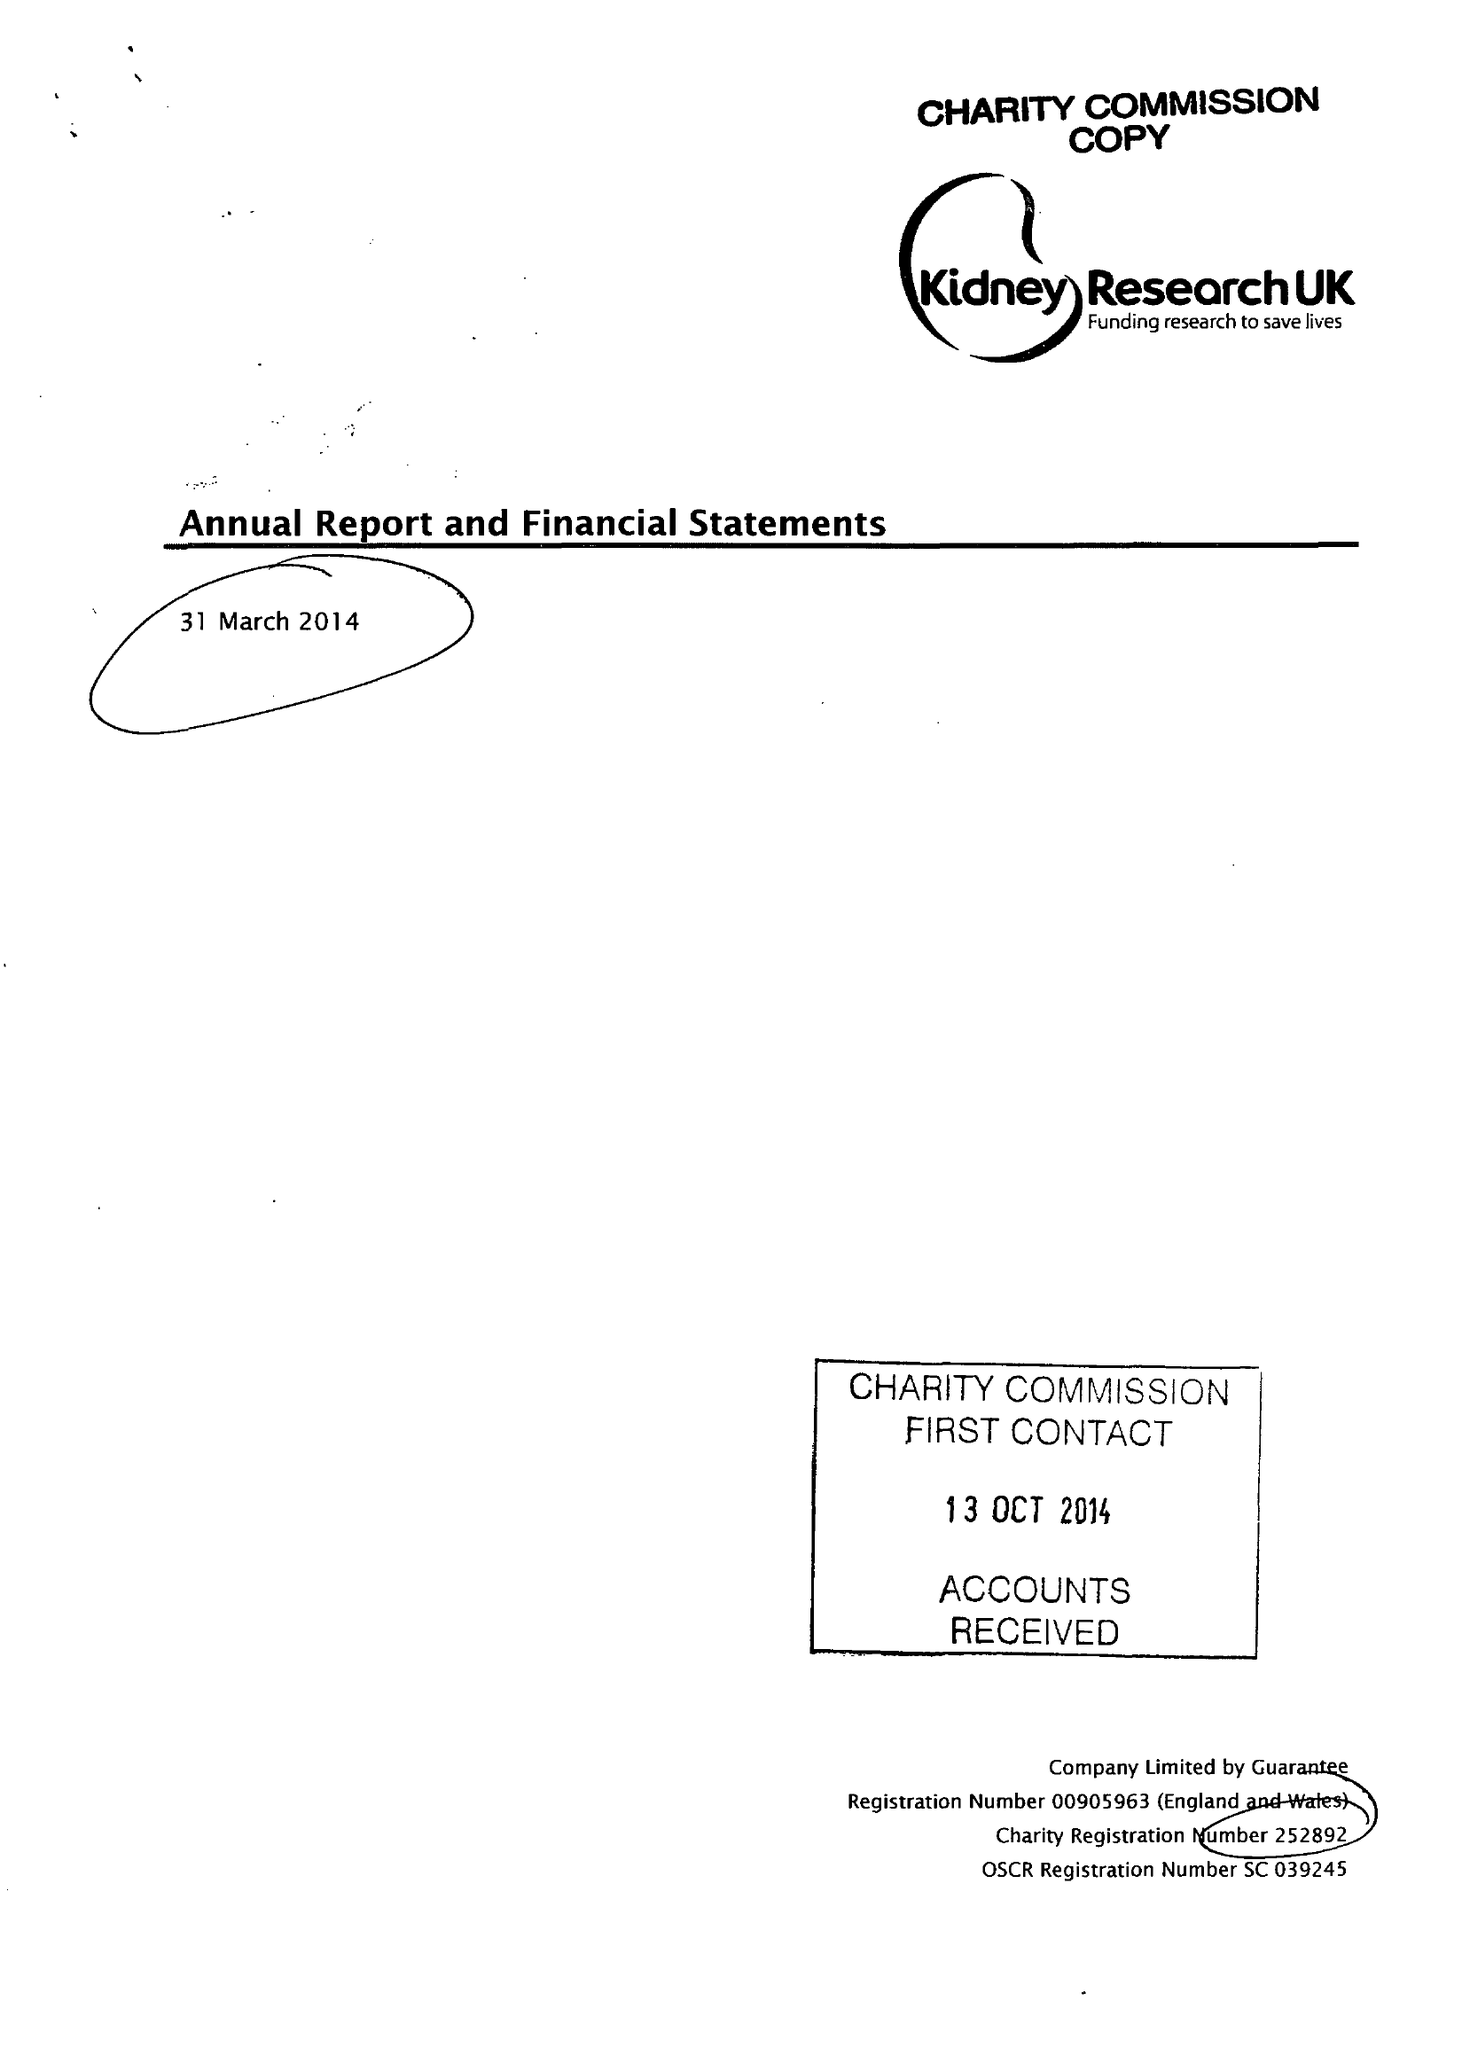What is the value for the report_date?
Answer the question using a single word or phrase. 2014-03-31 